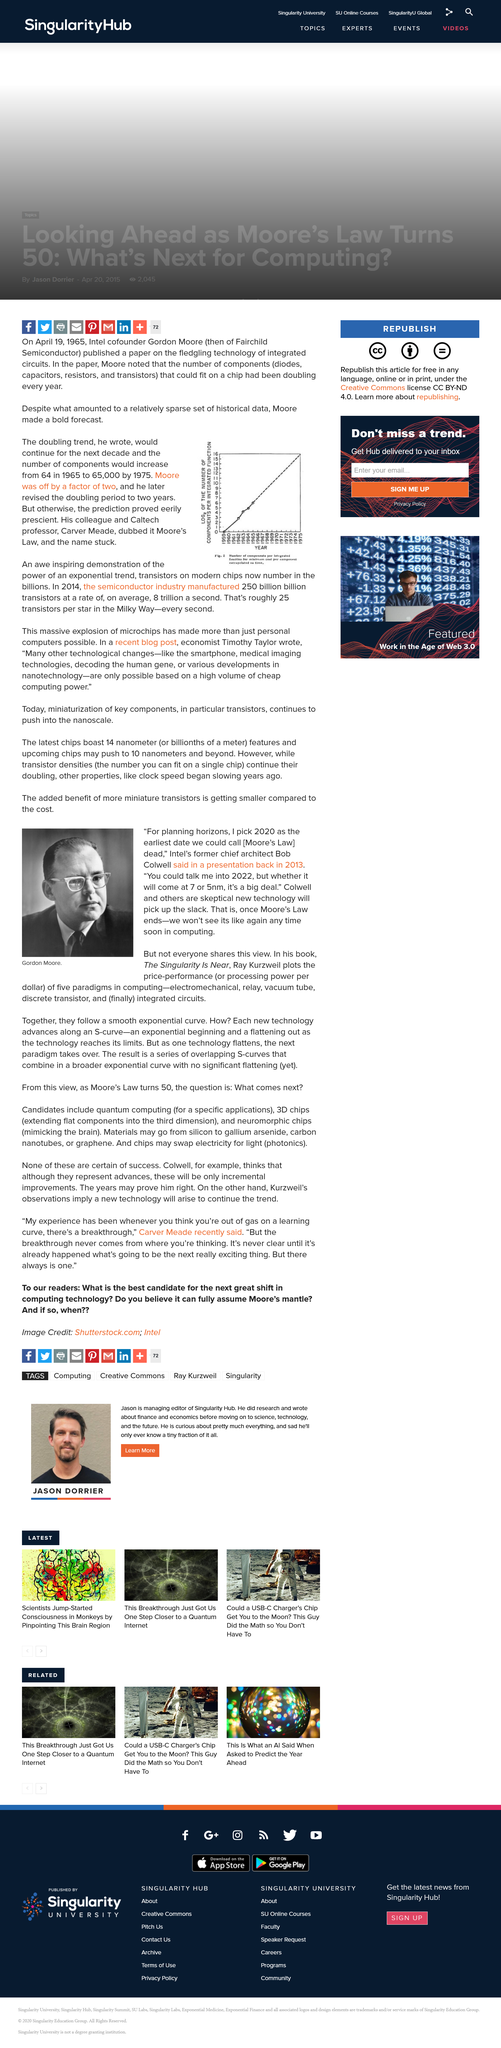Highlight a few significant elements in this photo. In 2014, the semiconductor industry manufactured approximately 250 billion billion transistors. Not everyone shares the view of Bob Colwell. The doubling trend would increase from 64 components in 1965 to 65,000 components in 1975, if the trend followed the doubling pattern every 10 years. The semiconductor industry manufactured 250 billion billion transistors in 2014, at an average rate of 8 trillion transistors per second. It is clear from the photograph that Gordon Moore is present. 